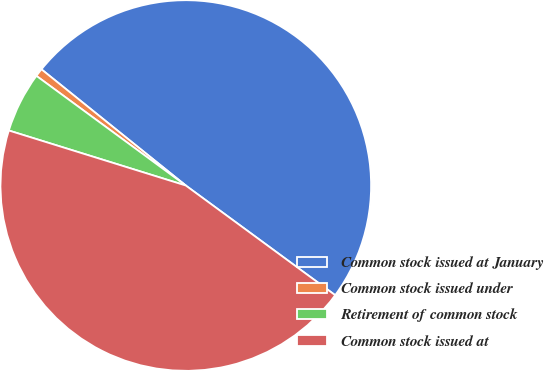<chart> <loc_0><loc_0><loc_500><loc_500><pie_chart><fcel>Common stock issued at January<fcel>Common stock issued under<fcel>Retirement of common stock<fcel>Common stock issued at<nl><fcel>49.29%<fcel>0.71%<fcel>5.28%<fcel>44.72%<nl></chart> 